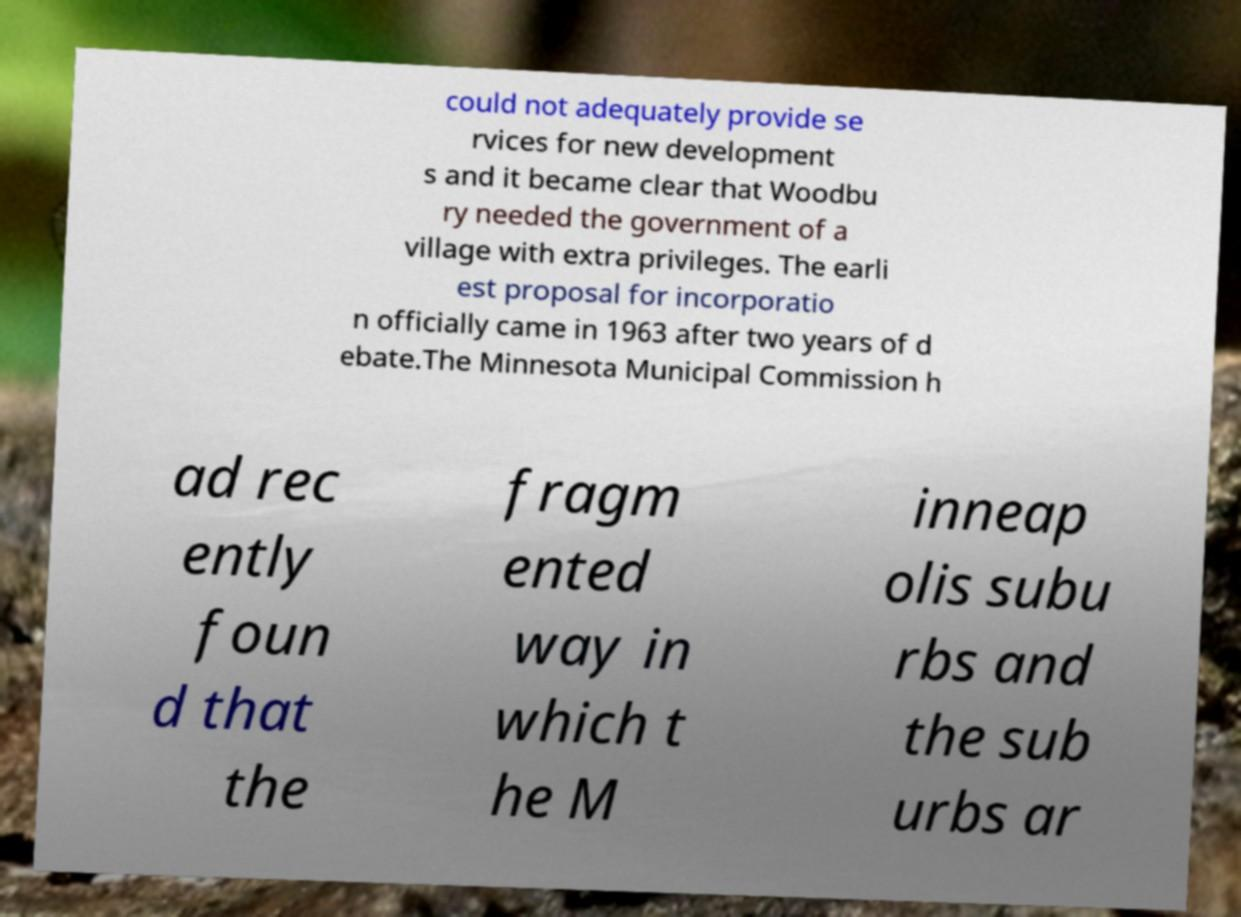Could you extract and type out the text from this image? could not adequately provide se rvices for new development s and it became clear that Woodbu ry needed the government of a village with extra privileges. The earli est proposal for incorporatio n officially came in 1963 after two years of d ebate.The Minnesota Municipal Commission h ad rec ently foun d that the fragm ented way in which t he M inneap olis subu rbs and the sub urbs ar 